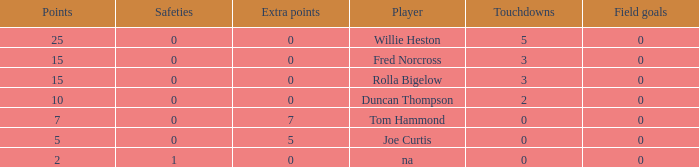How many Touchdowns have a Player of rolla bigelow, and an Extra points smaller than 0? None. 